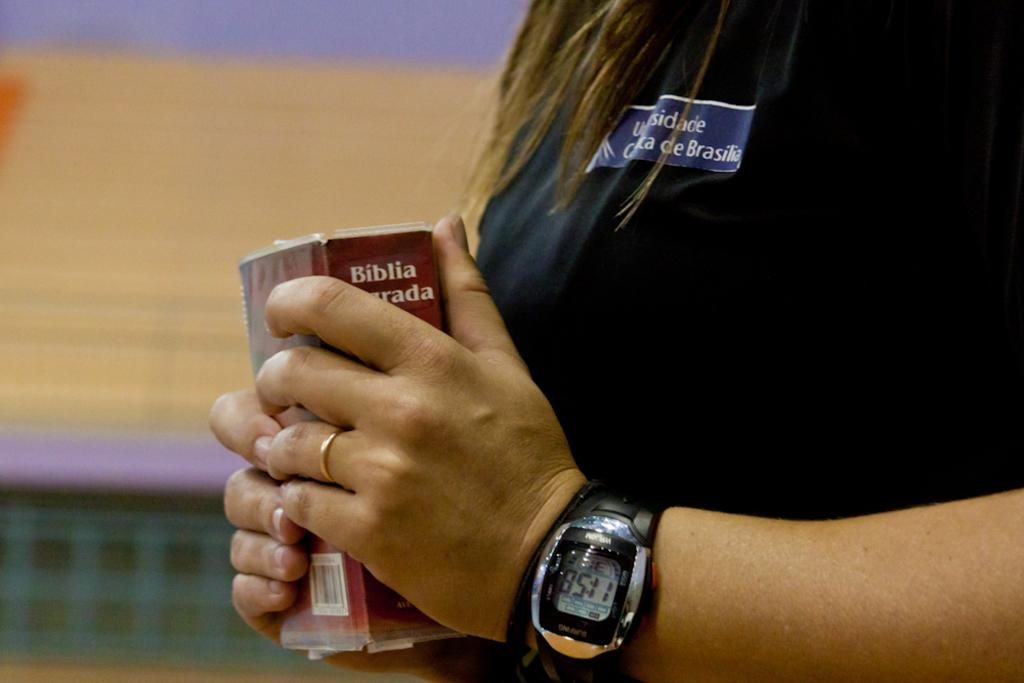<image>
Describe the image concisely. A person wearing a watch with 11:58 on it. 